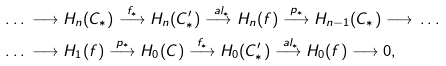<formula> <loc_0><loc_0><loc_500><loc_500>& \dots \, \longrightarrow H _ { n } ( C _ { * } ) \overset { f _ { * } } { \longrightarrow } H _ { n } ( C ^ { \prime } _ { * } ) \overset { \ a l _ { * } } { \longrightarrow } H _ { n } ( f ) \overset { p _ { * } } { \longrightarrow } H _ { n - 1 } ( C _ { * } ) \longrightarrow \, \dots \\ & \dots \, \longrightarrow H _ { 1 } ( f ) \overset { p _ { * } } { \longrightarrow } H _ { 0 } ( C ) \overset { f _ { * } } { \longrightarrow } H _ { 0 } ( C ^ { \prime } _ { * } ) \overset { \ a l _ { * } } { \longrightarrow } H _ { 0 } ( f ) \longrightarrow 0 ,</formula> 